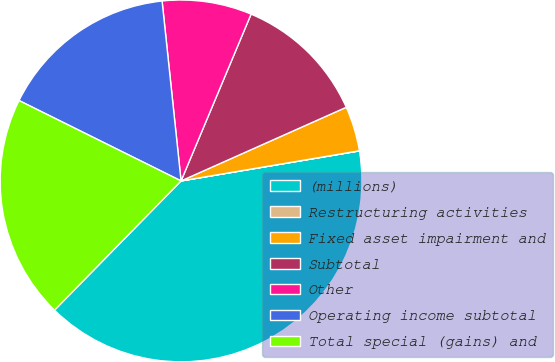Convert chart to OTSL. <chart><loc_0><loc_0><loc_500><loc_500><pie_chart><fcel>(millions)<fcel>Restructuring activities<fcel>Fixed asset impairment and<fcel>Subtotal<fcel>Other<fcel>Operating income subtotal<fcel>Total special (gains) and<nl><fcel>39.99%<fcel>0.01%<fcel>4.01%<fcel>12.0%<fcel>8.0%<fcel>16.0%<fcel>20.0%<nl></chart> 